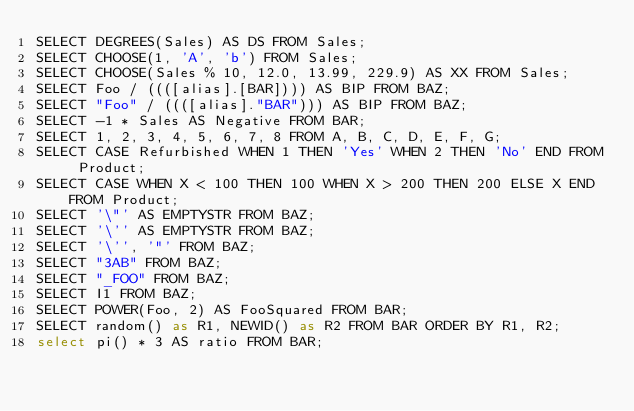Convert code to text. <code><loc_0><loc_0><loc_500><loc_500><_SQL_>SELECT DEGREES(Sales) AS DS FROM Sales;
SELECT CHOOSE(1, 'A', 'b') FROM Sales;
SELECT CHOOSE(Sales % 10, 12.0, 13.99, 229.9) AS XX FROM Sales;
SELECT Foo / ((([alias].[BAR]))) AS BIP FROM BAZ;
SELECT "Foo" / ((([alias]."BAR"))) AS BIP FROM BAZ;
SELECT -1 * Sales AS Negative FROM BAR;
SELECT 1, 2, 3, 4, 5, 6, 7, 8 FROM A, B, C, D, E, F, G;
SELECT CASE Refurbished WHEN 1 THEN 'Yes' WHEN 2 THEN 'No' END FROM Product;
SELECT CASE WHEN X < 100 THEN 100 WHEN X > 200 THEN 200 ELSE X END FROM Product;
SELECT '\"' AS EMPTYSTR FROM BAZ;
SELECT '\'' AS EMPTYSTR FROM BAZ;
SELECT '\'', '"' FROM BAZ;
SELECT "3AB" FROM BAZ;
SELECT "_FOO" FROM BAZ;
SELECT I1 FROM BAZ;
SELECT POWER(Foo, 2) AS FooSquared FROM BAR;
SELECT random() as R1, NEWID() as R2 FROM BAR ORDER BY R1, R2;
select pi() * 3 AS ratio FROM BAR;</code> 